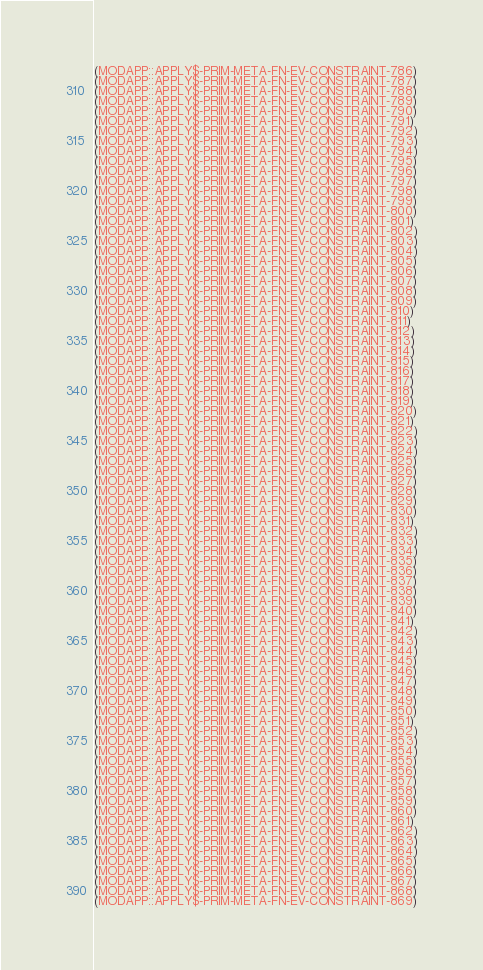<code> <loc_0><loc_0><loc_500><loc_500><_Lisp_>(MODAPP::APPLY$-PRIM-META-FN-EV-CONSTRAINT-786)
(MODAPP::APPLY$-PRIM-META-FN-EV-CONSTRAINT-787)
(MODAPP::APPLY$-PRIM-META-FN-EV-CONSTRAINT-788)
(MODAPP::APPLY$-PRIM-META-FN-EV-CONSTRAINT-789)
(MODAPP::APPLY$-PRIM-META-FN-EV-CONSTRAINT-790)
(MODAPP::APPLY$-PRIM-META-FN-EV-CONSTRAINT-791)
(MODAPP::APPLY$-PRIM-META-FN-EV-CONSTRAINT-792)
(MODAPP::APPLY$-PRIM-META-FN-EV-CONSTRAINT-793)
(MODAPP::APPLY$-PRIM-META-FN-EV-CONSTRAINT-794)
(MODAPP::APPLY$-PRIM-META-FN-EV-CONSTRAINT-795)
(MODAPP::APPLY$-PRIM-META-FN-EV-CONSTRAINT-796)
(MODAPP::APPLY$-PRIM-META-FN-EV-CONSTRAINT-797)
(MODAPP::APPLY$-PRIM-META-FN-EV-CONSTRAINT-798)
(MODAPP::APPLY$-PRIM-META-FN-EV-CONSTRAINT-799)
(MODAPP::APPLY$-PRIM-META-FN-EV-CONSTRAINT-800)
(MODAPP::APPLY$-PRIM-META-FN-EV-CONSTRAINT-801)
(MODAPP::APPLY$-PRIM-META-FN-EV-CONSTRAINT-802)
(MODAPP::APPLY$-PRIM-META-FN-EV-CONSTRAINT-803)
(MODAPP::APPLY$-PRIM-META-FN-EV-CONSTRAINT-804)
(MODAPP::APPLY$-PRIM-META-FN-EV-CONSTRAINT-805)
(MODAPP::APPLY$-PRIM-META-FN-EV-CONSTRAINT-806)
(MODAPP::APPLY$-PRIM-META-FN-EV-CONSTRAINT-807)
(MODAPP::APPLY$-PRIM-META-FN-EV-CONSTRAINT-808)
(MODAPP::APPLY$-PRIM-META-FN-EV-CONSTRAINT-809)
(MODAPP::APPLY$-PRIM-META-FN-EV-CONSTRAINT-810)
(MODAPP::APPLY$-PRIM-META-FN-EV-CONSTRAINT-811)
(MODAPP::APPLY$-PRIM-META-FN-EV-CONSTRAINT-812)
(MODAPP::APPLY$-PRIM-META-FN-EV-CONSTRAINT-813)
(MODAPP::APPLY$-PRIM-META-FN-EV-CONSTRAINT-814)
(MODAPP::APPLY$-PRIM-META-FN-EV-CONSTRAINT-815)
(MODAPP::APPLY$-PRIM-META-FN-EV-CONSTRAINT-816)
(MODAPP::APPLY$-PRIM-META-FN-EV-CONSTRAINT-817)
(MODAPP::APPLY$-PRIM-META-FN-EV-CONSTRAINT-818)
(MODAPP::APPLY$-PRIM-META-FN-EV-CONSTRAINT-819)
(MODAPP::APPLY$-PRIM-META-FN-EV-CONSTRAINT-820)
(MODAPP::APPLY$-PRIM-META-FN-EV-CONSTRAINT-821)
(MODAPP::APPLY$-PRIM-META-FN-EV-CONSTRAINT-822)
(MODAPP::APPLY$-PRIM-META-FN-EV-CONSTRAINT-823)
(MODAPP::APPLY$-PRIM-META-FN-EV-CONSTRAINT-824)
(MODAPP::APPLY$-PRIM-META-FN-EV-CONSTRAINT-825)
(MODAPP::APPLY$-PRIM-META-FN-EV-CONSTRAINT-826)
(MODAPP::APPLY$-PRIM-META-FN-EV-CONSTRAINT-827)
(MODAPP::APPLY$-PRIM-META-FN-EV-CONSTRAINT-828)
(MODAPP::APPLY$-PRIM-META-FN-EV-CONSTRAINT-829)
(MODAPP::APPLY$-PRIM-META-FN-EV-CONSTRAINT-830)
(MODAPP::APPLY$-PRIM-META-FN-EV-CONSTRAINT-831)
(MODAPP::APPLY$-PRIM-META-FN-EV-CONSTRAINT-832)
(MODAPP::APPLY$-PRIM-META-FN-EV-CONSTRAINT-833)
(MODAPP::APPLY$-PRIM-META-FN-EV-CONSTRAINT-834)
(MODAPP::APPLY$-PRIM-META-FN-EV-CONSTRAINT-835)
(MODAPP::APPLY$-PRIM-META-FN-EV-CONSTRAINT-836)
(MODAPP::APPLY$-PRIM-META-FN-EV-CONSTRAINT-837)
(MODAPP::APPLY$-PRIM-META-FN-EV-CONSTRAINT-838)
(MODAPP::APPLY$-PRIM-META-FN-EV-CONSTRAINT-839)
(MODAPP::APPLY$-PRIM-META-FN-EV-CONSTRAINT-840)
(MODAPP::APPLY$-PRIM-META-FN-EV-CONSTRAINT-841)
(MODAPP::APPLY$-PRIM-META-FN-EV-CONSTRAINT-842)
(MODAPP::APPLY$-PRIM-META-FN-EV-CONSTRAINT-843)
(MODAPP::APPLY$-PRIM-META-FN-EV-CONSTRAINT-844)
(MODAPP::APPLY$-PRIM-META-FN-EV-CONSTRAINT-845)
(MODAPP::APPLY$-PRIM-META-FN-EV-CONSTRAINT-846)
(MODAPP::APPLY$-PRIM-META-FN-EV-CONSTRAINT-847)
(MODAPP::APPLY$-PRIM-META-FN-EV-CONSTRAINT-848)
(MODAPP::APPLY$-PRIM-META-FN-EV-CONSTRAINT-849)
(MODAPP::APPLY$-PRIM-META-FN-EV-CONSTRAINT-850)
(MODAPP::APPLY$-PRIM-META-FN-EV-CONSTRAINT-851)
(MODAPP::APPLY$-PRIM-META-FN-EV-CONSTRAINT-852)
(MODAPP::APPLY$-PRIM-META-FN-EV-CONSTRAINT-853)
(MODAPP::APPLY$-PRIM-META-FN-EV-CONSTRAINT-854)
(MODAPP::APPLY$-PRIM-META-FN-EV-CONSTRAINT-855)
(MODAPP::APPLY$-PRIM-META-FN-EV-CONSTRAINT-856)
(MODAPP::APPLY$-PRIM-META-FN-EV-CONSTRAINT-857)
(MODAPP::APPLY$-PRIM-META-FN-EV-CONSTRAINT-858)
(MODAPP::APPLY$-PRIM-META-FN-EV-CONSTRAINT-859)
(MODAPP::APPLY$-PRIM-META-FN-EV-CONSTRAINT-860)
(MODAPP::APPLY$-PRIM-META-FN-EV-CONSTRAINT-861)
(MODAPP::APPLY$-PRIM-META-FN-EV-CONSTRAINT-862)
(MODAPP::APPLY$-PRIM-META-FN-EV-CONSTRAINT-863)
(MODAPP::APPLY$-PRIM-META-FN-EV-CONSTRAINT-864)
(MODAPP::APPLY$-PRIM-META-FN-EV-CONSTRAINT-865)
(MODAPP::APPLY$-PRIM-META-FN-EV-CONSTRAINT-866)
(MODAPP::APPLY$-PRIM-META-FN-EV-CONSTRAINT-867)
(MODAPP::APPLY$-PRIM-META-FN-EV-CONSTRAINT-868)
(MODAPP::APPLY$-PRIM-META-FN-EV-CONSTRAINT-869)</code> 